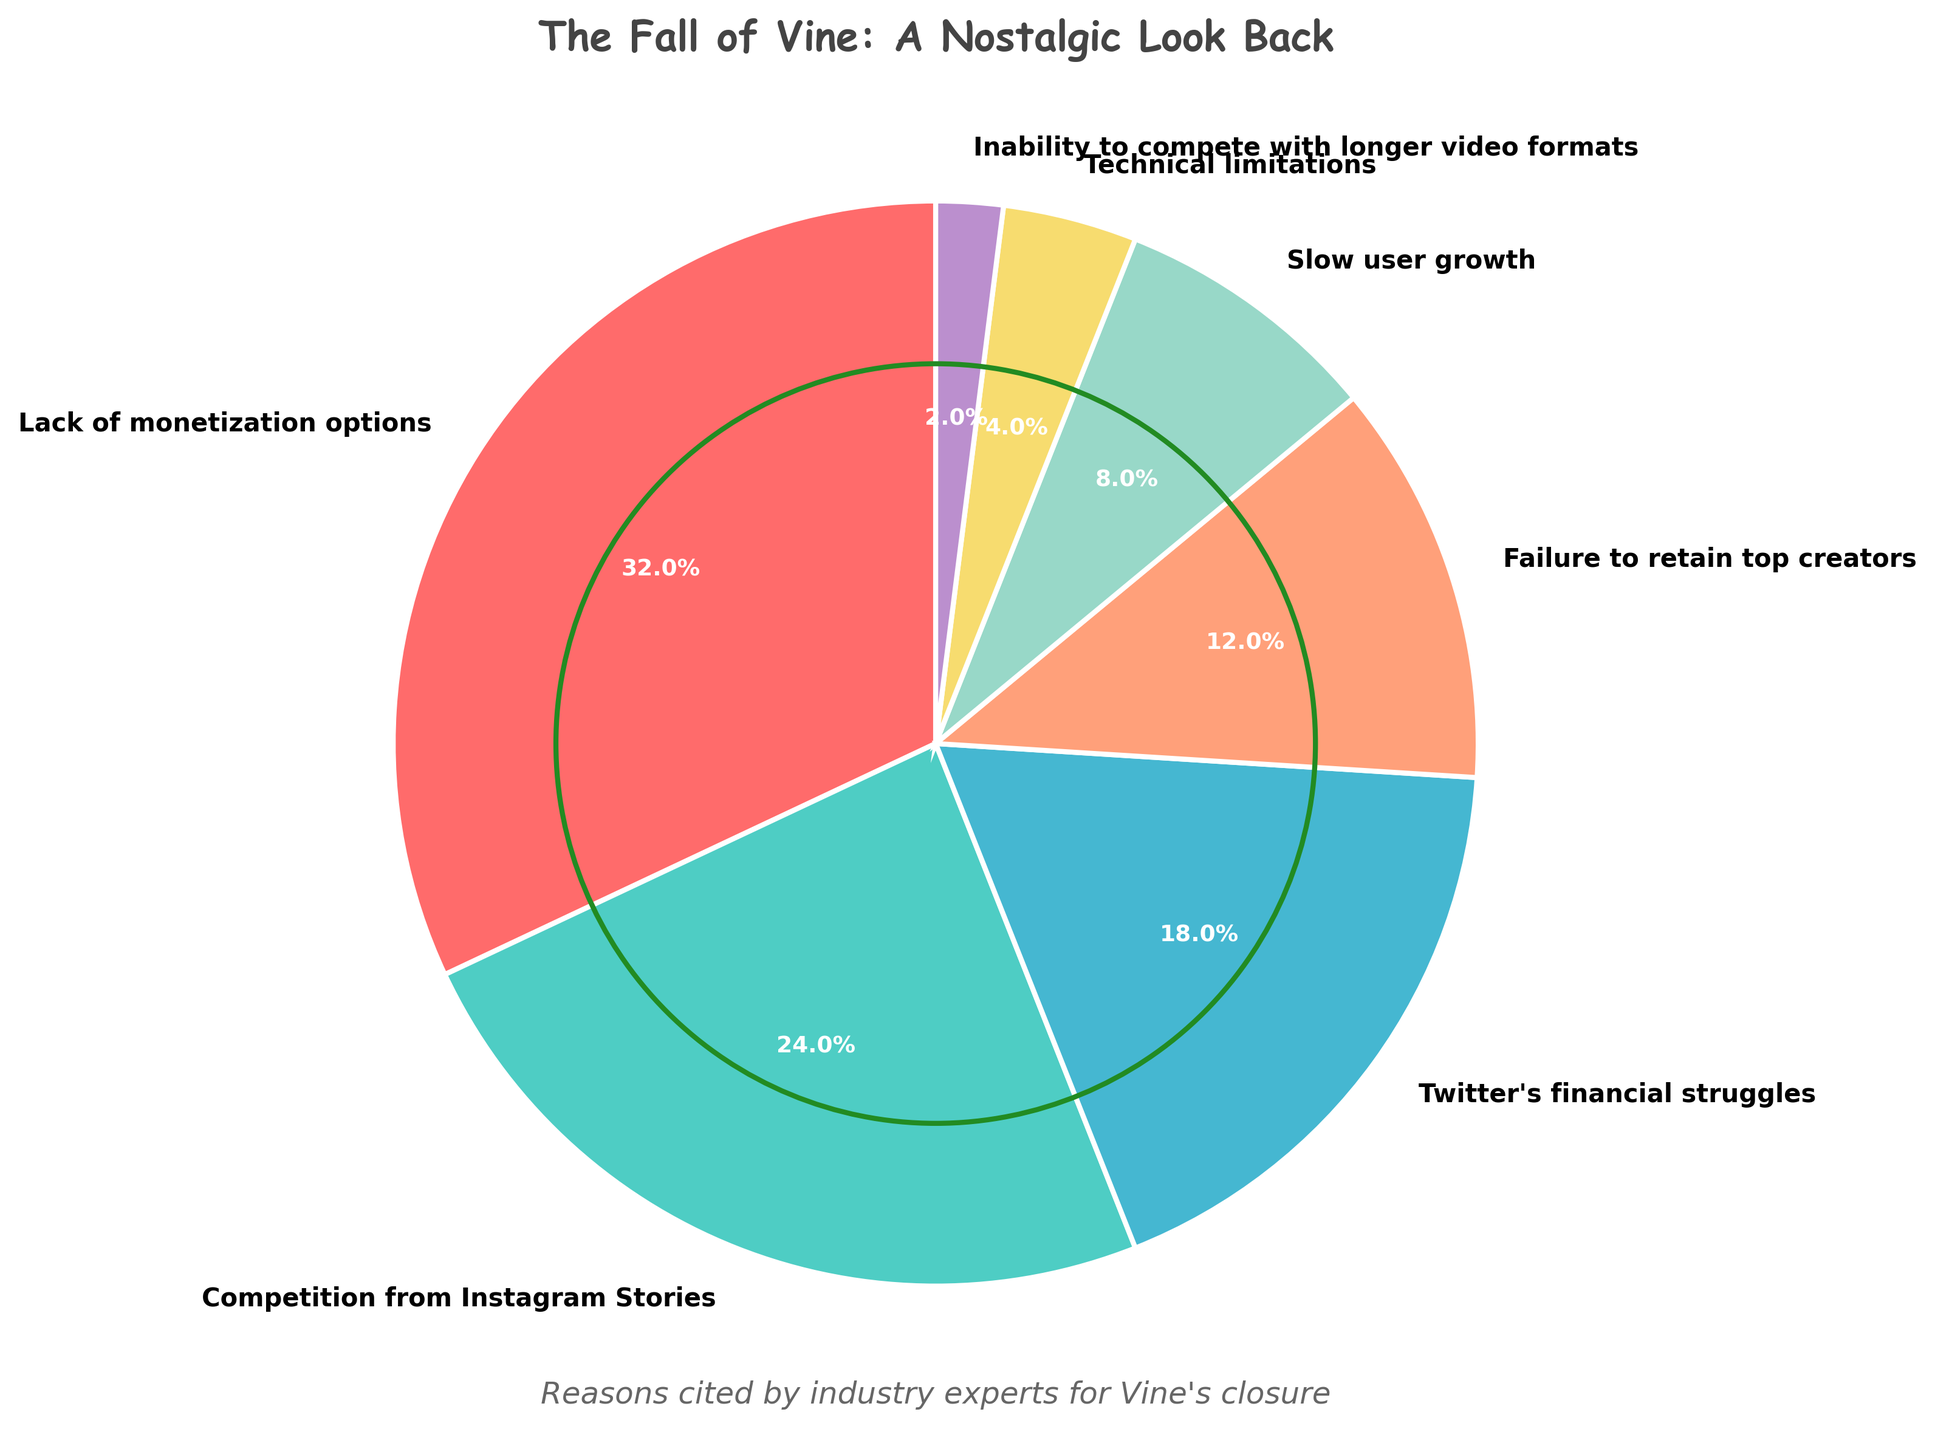What reason was cited by the highest percentage of industry experts for Vine's closure? The segment with the largest percentage is labeled as "Lack of monetization options" with 32%.
Answer: Lack of monetization options Which reason was mentioned more frequently: "Competition from Instagram Stories" or "Twitter's financial struggles"? By comparing the two segments, "Competition from Instagram Stories" has a larger percentage (24%) compared to "Twitter's financial struggles" (18%).
Answer: Competition from Instagram Stories What is the total percentage of reasons related to external competition ("Competition from Instagram Stories" and "Inability to compete with longer video formats")? Add the percentages of these two segments: 24% + 2% = 26%.
Answer: 26% How much more frequently was "Failure to retain top creators" cited compared to "Technical limitations"? Subtract the percentage of "Technical limitations" (4%) from "Failure to retain top creators" (12%): 12% - 4% = 8%.
Answer: 8% Which section of the pie chart is the smallest and what percentage does it represent? The smallest section is labeled "Inability to compete with longer video formats," representing 2%.
Answer: Inability to compete with longer video formats, 2% How many reasons were cited by industry experts for Vine's closure? By counting the labeled segments in the pie chart, there are 7 reasons mentioned.
Answer: 7 What's the combined percentage of reasons related to Twitter's internal issues ("Twitter's financial struggles" and "Technical limitations")? Add the percentages of these two segments: 18% + 4% = 22%.
Answer: 22% Which reason cited for Vine's closure has a green-colored segment? By looking at the color palette, the green segment corresponds to "Competition from Instagram Stories" representing 24%.
Answer: Competition from Instagram Stories Is "Slow user growth" mentioned more frequently than "Failure to retain top creators"? Compare the percentages: "Slow user growth" is 8% and "Failure to retain top creators" is 12%. Slow user growth is mentioned less frequently.
Answer: No What’s the visual element added to the pie chart for decorative purposes? There is a green vine-like border circle that has been added around the pie chart as a decorative element.
Answer: Green vine-like border 